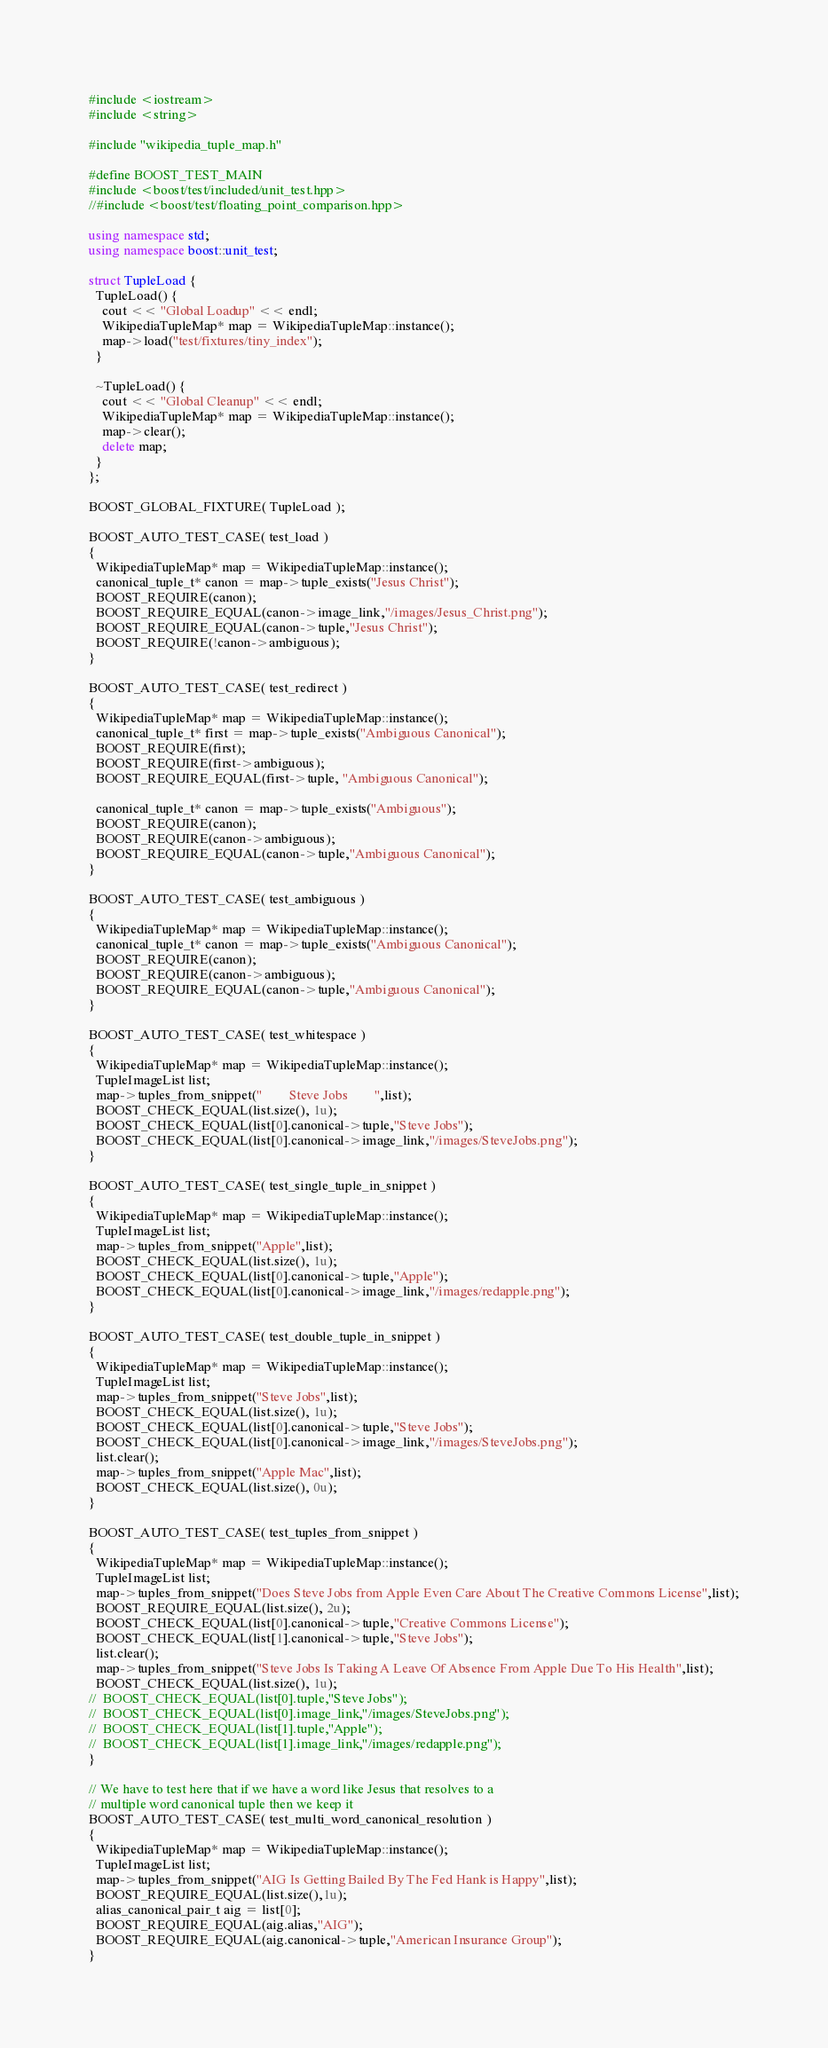Convert code to text. <code><loc_0><loc_0><loc_500><loc_500><_C++_>#include <iostream>
#include <string>

#include "wikipedia_tuple_map.h"

#define BOOST_TEST_MAIN
#include <boost/test/included/unit_test.hpp>
//#include <boost/test/floating_point_comparison.hpp>

using namespace std;
using namespace boost::unit_test;

struct TupleLoad {
  TupleLoad() {
    cout << "Global Loadup" << endl;
    WikipediaTupleMap* map = WikipediaTupleMap::instance();
    map->load("test/fixtures/tiny_index"); 
  }

  ~TupleLoad() {
    cout << "Global Cleanup" << endl;
    WikipediaTupleMap* map = WikipediaTupleMap::instance();
    map->clear();
    delete map;
  }
};

BOOST_GLOBAL_FIXTURE( TupleLoad );

BOOST_AUTO_TEST_CASE( test_load )
{
  WikipediaTupleMap* map = WikipediaTupleMap::instance();
  canonical_tuple_t* canon = map->tuple_exists("Jesus Christ");
  BOOST_REQUIRE(canon);
  BOOST_REQUIRE_EQUAL(canon->image_link,"/images/Jesus_Christ.png");
  BOOST_REQUIRE_EQUAL(canon->tuple,"Jesus Christ");
  BOOST_REQUIRE(!canon->ambiguous);
}

BOOST_AUTO_TEST_CASE( test_redirect )
{
  WikipediaTupleMap* map = WikipediaTupleMap::instance();
  canonical_tuple_t* first = map->tuple_exists("Ambiguous Canonical");
  BOOST_REQUIRE(first);
  BOOST_REQUIRE(first->ambiguous);
  BOOST_REQUIRE_EQUAL(first->tuple, "Ambiguous Canonical");

  canonical_tuple_t* canon = map->tuple_exists("Ambiguous");
  BOOST_REQUIRE(canon);
  BOOST_REQUIRE(canon->ambiguous);
  BOOST_REQUIRE_EQUAL(canon->tuple,"Ambiguous Canonical");
}

BOOST_AUTO_TEST_CASE( test_ambiguous )
{
  WikipediaTupleMap* map = WikipediaTupleMap::instance();
  canonical_tuple_t* canon = map->tuple_exists("Ambiguous Canonical");
  BOOST_REQUIRE(canon);
  BOOST_REQUIRE(canon->ambiguous);
  BOOST_REQUIRE_EQUAL(canon->tuple,"Ambiguous Canonical");
}

BOOST_AUTO_TEST_CASE( test_whitespace )
{
  WikipediaTupleMap* map = WikipediaTupleMap::instance();
  TupleImageList list;
  map->tuples_from_snippet("        Steve Jobs        ",list);
  BOOST_CHECK_EQUAL(list.size(), 1u);
  BOOST_CHECK_EQUAL(list[0].canonical->tuple,"Steve Jobs");
  BOOST_CHECK_EQUAL(list[0].canonical->image_link,"/images/SteveJobs.png");
}

BOOST_AUTO_TEST_CASE( test_single_tuple_in_snippet )
{
  WikipediaTupleMap* map = WikipediaTupleMap::instance();
  TupleImageList list;
  map->tuples_from_snippet("Apple",list);
  BOOST_CHECK_EQUAL(list.size(), 1u);
  BOOST_CHECK_EQUAL(list[0].canonical->tuple,"Apple");
  BOOST_CHECK_EQUAL(list[0].canonical->image_link,"/images/redapple.png");
}

BOOST_AUTO_TEST_CASE( test_double_tuple_in_snippet )
{
  WikipediaTupleMap* map = WikipediaTupleMap::instance();
  TupleImageList list;
  map->tuples_from_snippet("Steve Jobs",list);
  BOOST_CHECK_EQUAL(list.size(), 1u);
  BOOST_CHECK_EQUAL(list[0].canonical->tuple,"Steve Jobs");
  BOOST_CHECK_EQUAL(list[0].canonical->image_link,"/images/SteveJobs.png");
  list.clear();
  map->tuples_from_snippet("Apple Mac",list);
  BOOST_CHECK_EQUAL(list.size(), 0u);
}

BOOST_AUTO_TEST_CASE( test_tuples_from_snippet )
{
  WikipediaTupleMap* map = WikipediaTupleMap::instance();
  TupleImageList list;
  map->tuples_from_snippet("Does Steve Jobs from Apple Even Care About The Creative Commons License",list);
  BOOST_REQUIRE_EQUAL(list.size(), 2u);
  BOOST_CHECK_EQUAL(list[0].canonical->tuple,"Creative Commons License");
  BOOST_CHECK_EQUAL(list[1].canonical->tuple,"Steve Jobs");
  list.clear();
  map->tuples_from_snippet("Steve Jobs Is Taking A Leave Of Absence From Apple Due To His Health",list);
  BOOST_CHECK_EQUAL(list.size(), 1u);
//  BOOST_CHECK_EQUAL(list[0].tuple,"Steve Jobs");
//  BOOST_CHECK_EQUAL(list[0].image_link,"/images/SteveJobs.png");
//  BOOST_CHECK_EQUAL(list[1].tuple,"Apple");
//  BOOST_CHECK_EQUAL(list[1].image_link,"/images/redapple.png");
}

// We have to test here that if we have a word like Jesus that resolves to a
// multiple word canonical tuple then we keep it
BOOST_AUTO_TEST_CASE( test_multi_word_canonical_resolution )
{
  WikipediaTupleMap* map = WikipediaTupleMap::instance();
  TupleImageList list;
  map->tuples_from_snippet("AIG Is Getting Bailed By The Fed Hank is Happy",list);
  BOOST_REQUIRE_EQUAL(list.size(),1u);
  alias_canonical_pair_t aig = list[0];
  BOOST_REQUIRE_EQUAL(aig.alias,"AIG");
  BOOST_REQUIRE_EQUAL(aig.canonical->tuple,"American Insurance Group");
}


</code> 